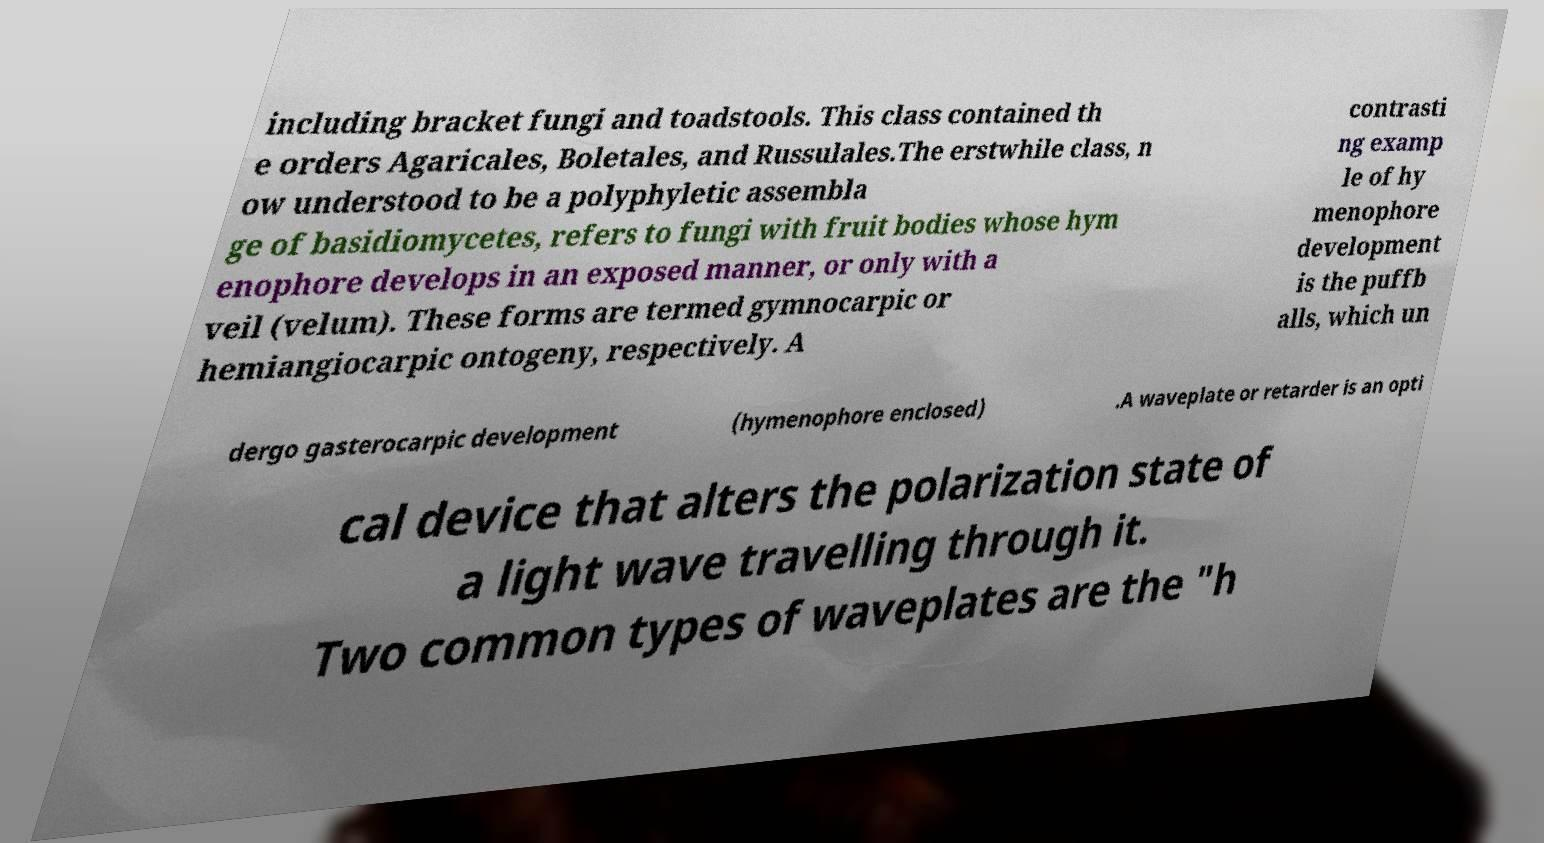For documentation purposes, I need the text within this image transcribed. Could you provide that? including bracket fungi and toadstools. This class contained th e orders Agaricales, Boletales, and Russulales.The erstwhile class, n ow understood to be a polyphyletic assembla ge of basidiomycetes, refers to fungi with fruit bodies whose hym enophore develops in an exposed manner, or only with a veil (velum). These forms are termed gymnocarpic or hemiangiocarpic ontogeny, respectively. A contrasti ng examp le of hy menophore development is the puffb alls, which un dergo gasterocarpic development (hymenophore enclosed) .A waveplate or retarder is an opti cal device that alters the polarization state of a light wave travelling through it. Two common types of waveplates are the "h 